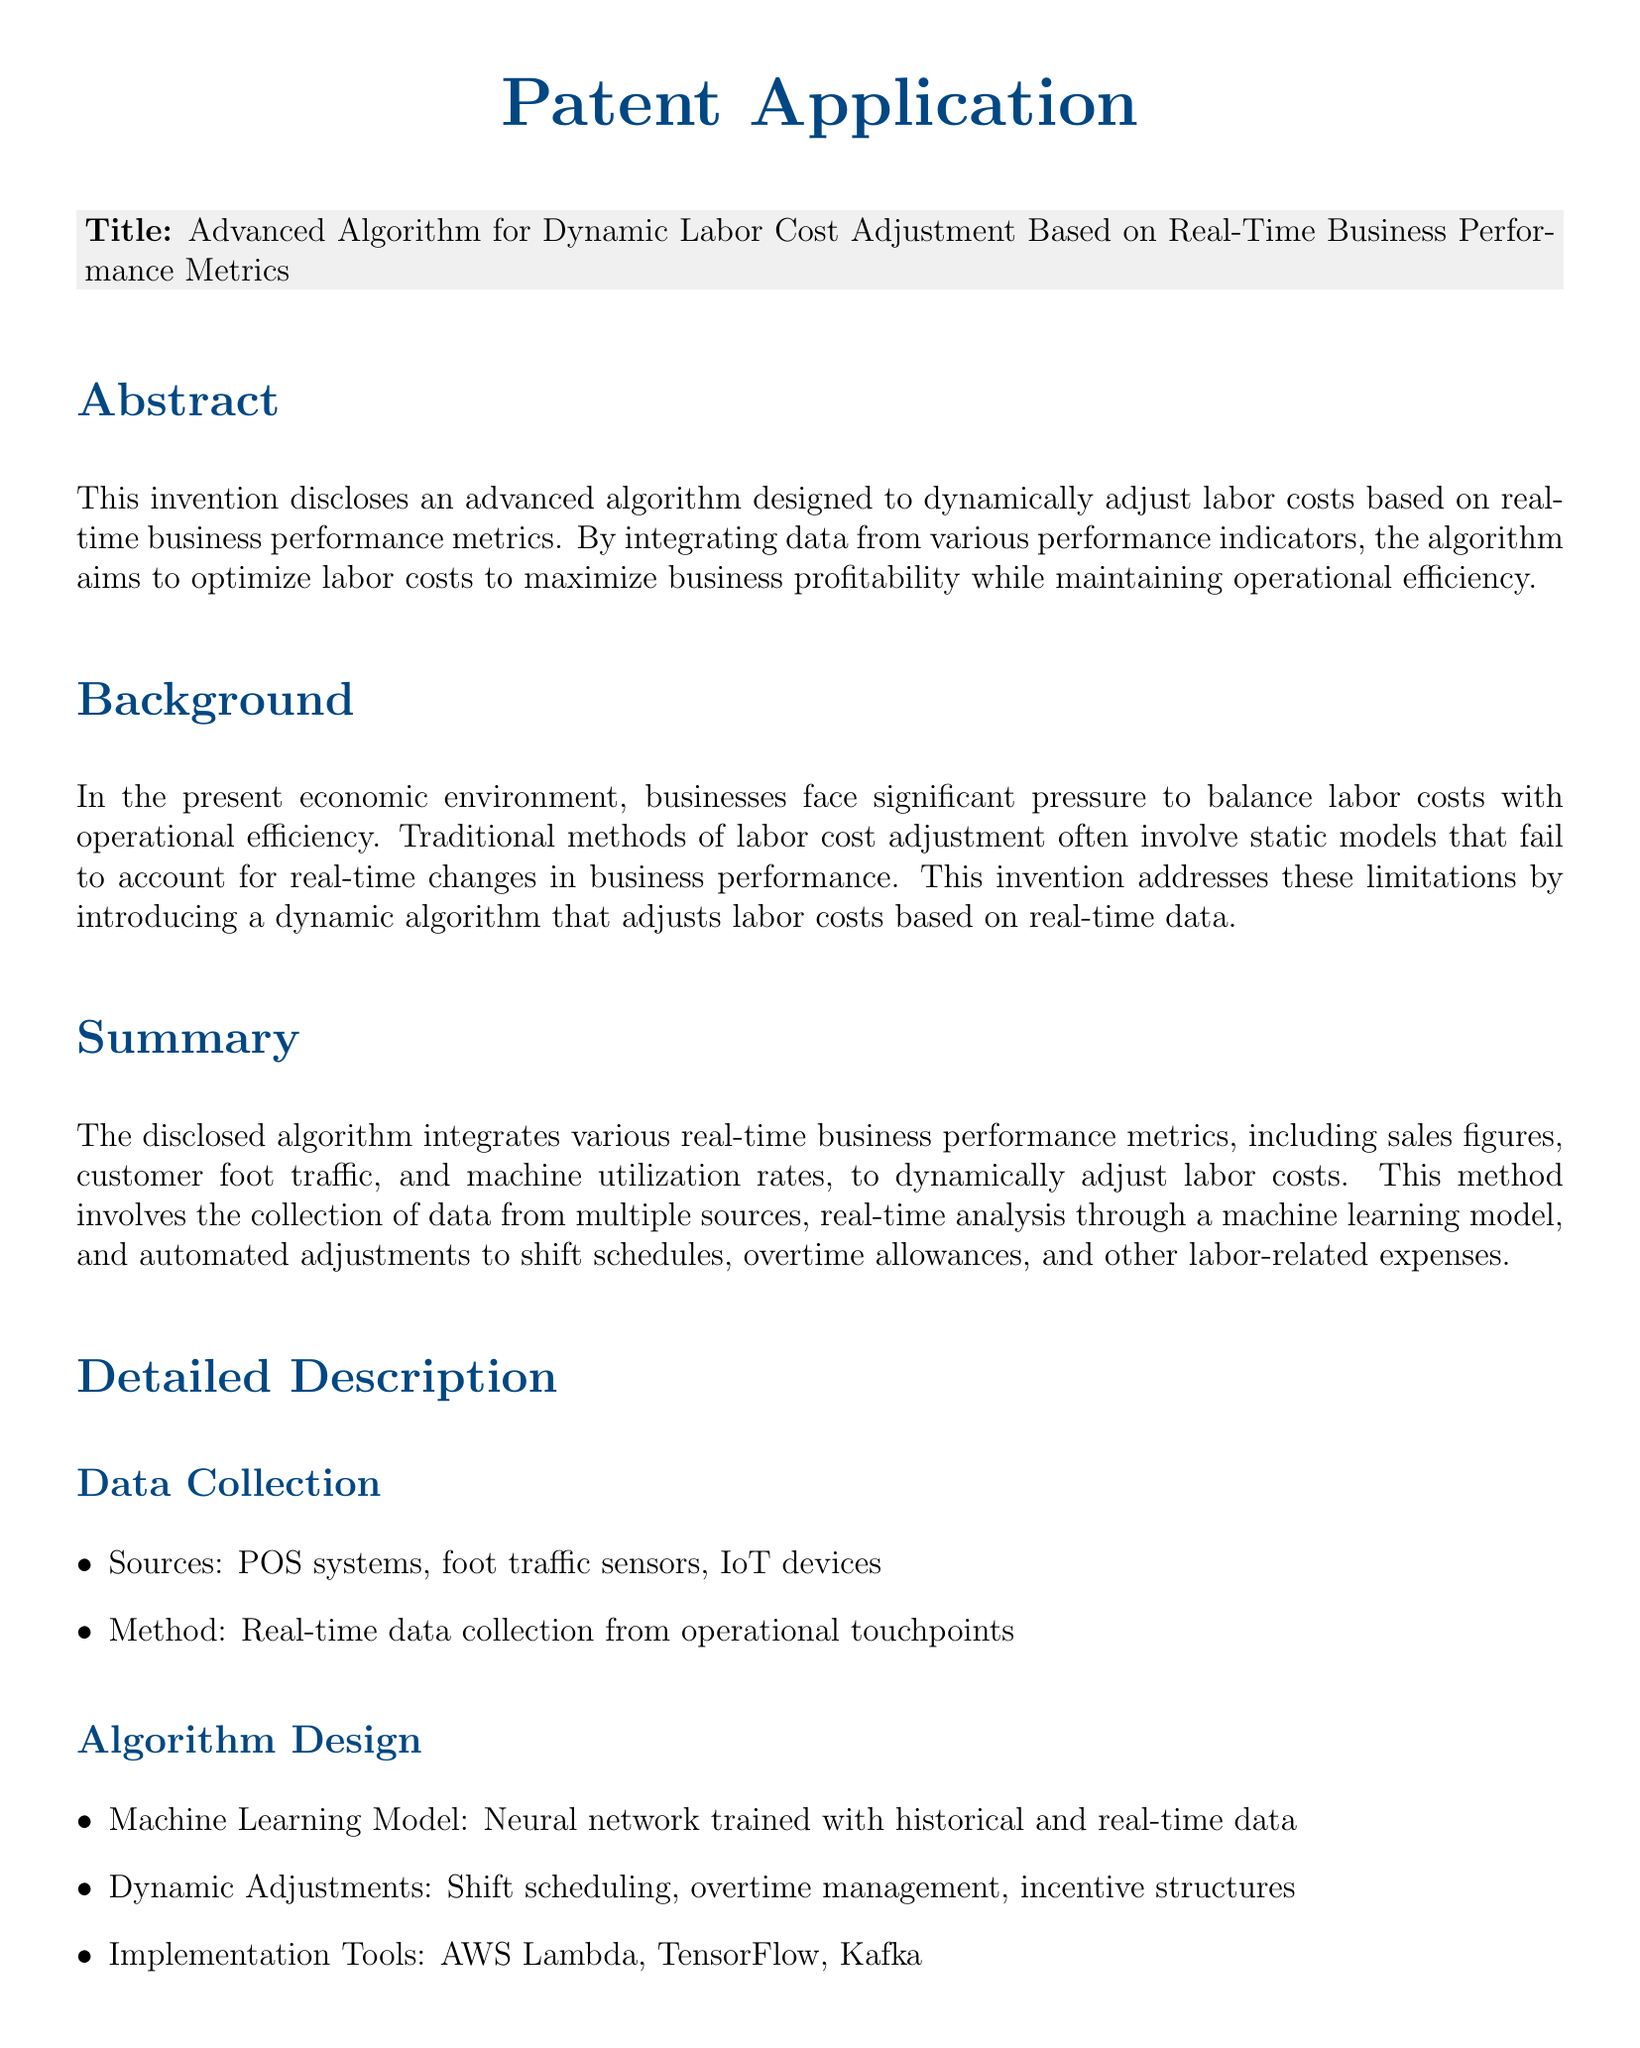what is the title of the patent? The title is stated in the document and is used to identify the invention.
Answer: Advanced Algorithm for Dynamic Labor Cost Adjustment Based on Real-Time Business Performance Metrics who are the inventors of the patent? The inventors are mentioned directly in the document, listing their names and addresses.
Answer: John Doe and Jane Smith what are the main sources of data for the algorithm? The sources of data collection are outlined in the detailed description section, focusing on the collection of real-time metrics.
Answer: POS systems, foot traffic sensors, IoT devices what is the machine learning model used in the algorithm? The document specifies the type of model designed for the specific function of analysis within the algorithm.
Answer: Neural network what are the advantages of this algorithm? The advantages listed in the document highlight the key benefits of the proposed system.
Answer: Increased profitability through optimized labor costs how does the algorithm adjust labor costs? The document describes the applicability of the algorithm in terms of operational adjustments in labor management.
Answer: Automated adjustments to shift schedules, overtime allowances, and other labor-related expenses which company is the assignee of the patent? The assignee is identified in the document, which denotes ownership of the patent rights.
Answer: ProfitMax Solutions Inc how does the algorithm enhance operational efficiency? The details in the advantages section provide insight into how the algorithm improves business operations.
Answer: Enhanced operational efficiency what tools are mentioned for implementation? The document lists specific tools used for the practical application of the algorithm.
Answer: AWS Lambda, TensorFlow, Kafka 